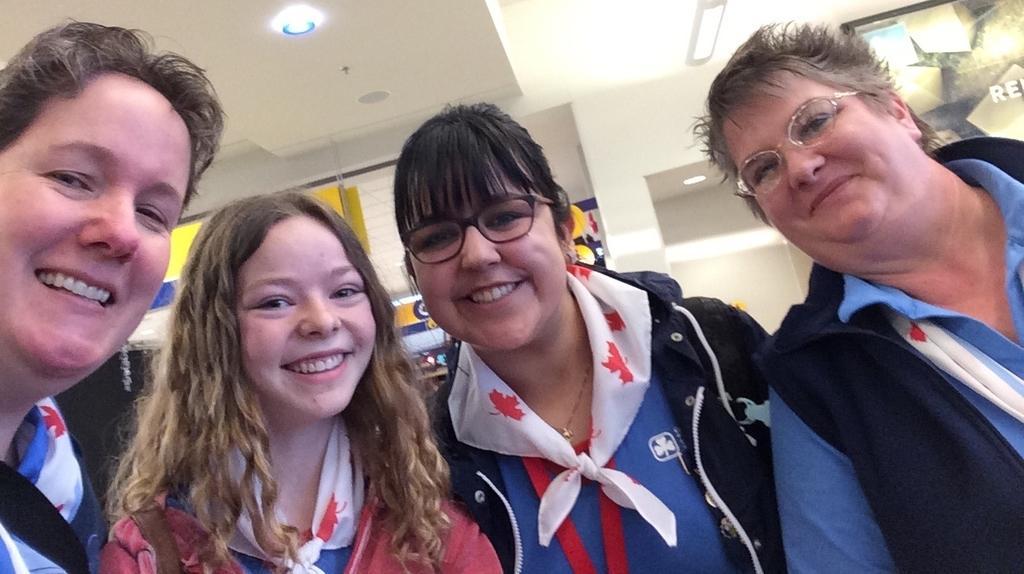Describe this image in one or two sentences. This image consists of four persons. In the background, there is a wall. At the top, there is a roof. 